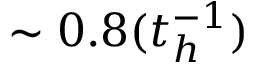Convert formula to latex. <formula><loc_0><loc_0><loc_500><loc_500>\sim 0 . 8 ( t _ { h } ^ { - 1 } )</formula> 